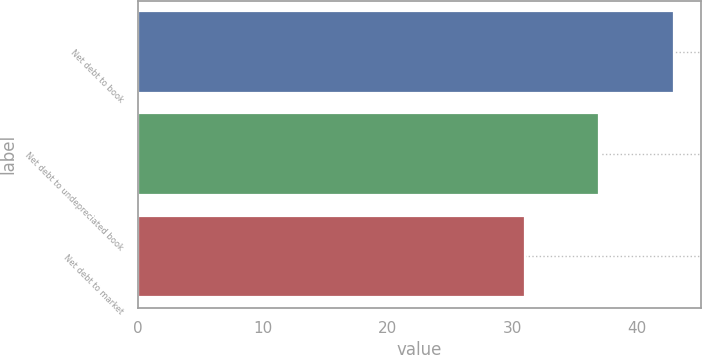Convert chart to OTSL. <chart><loc_0><loc_0><loc_500><loc_500><bar_chart><fcel>Net debt to book<fcel>Net debt to undepreciated book<fcel>Net debt to market<nl><fcel>43<fcel>37<fcel>31<nl></chart> 